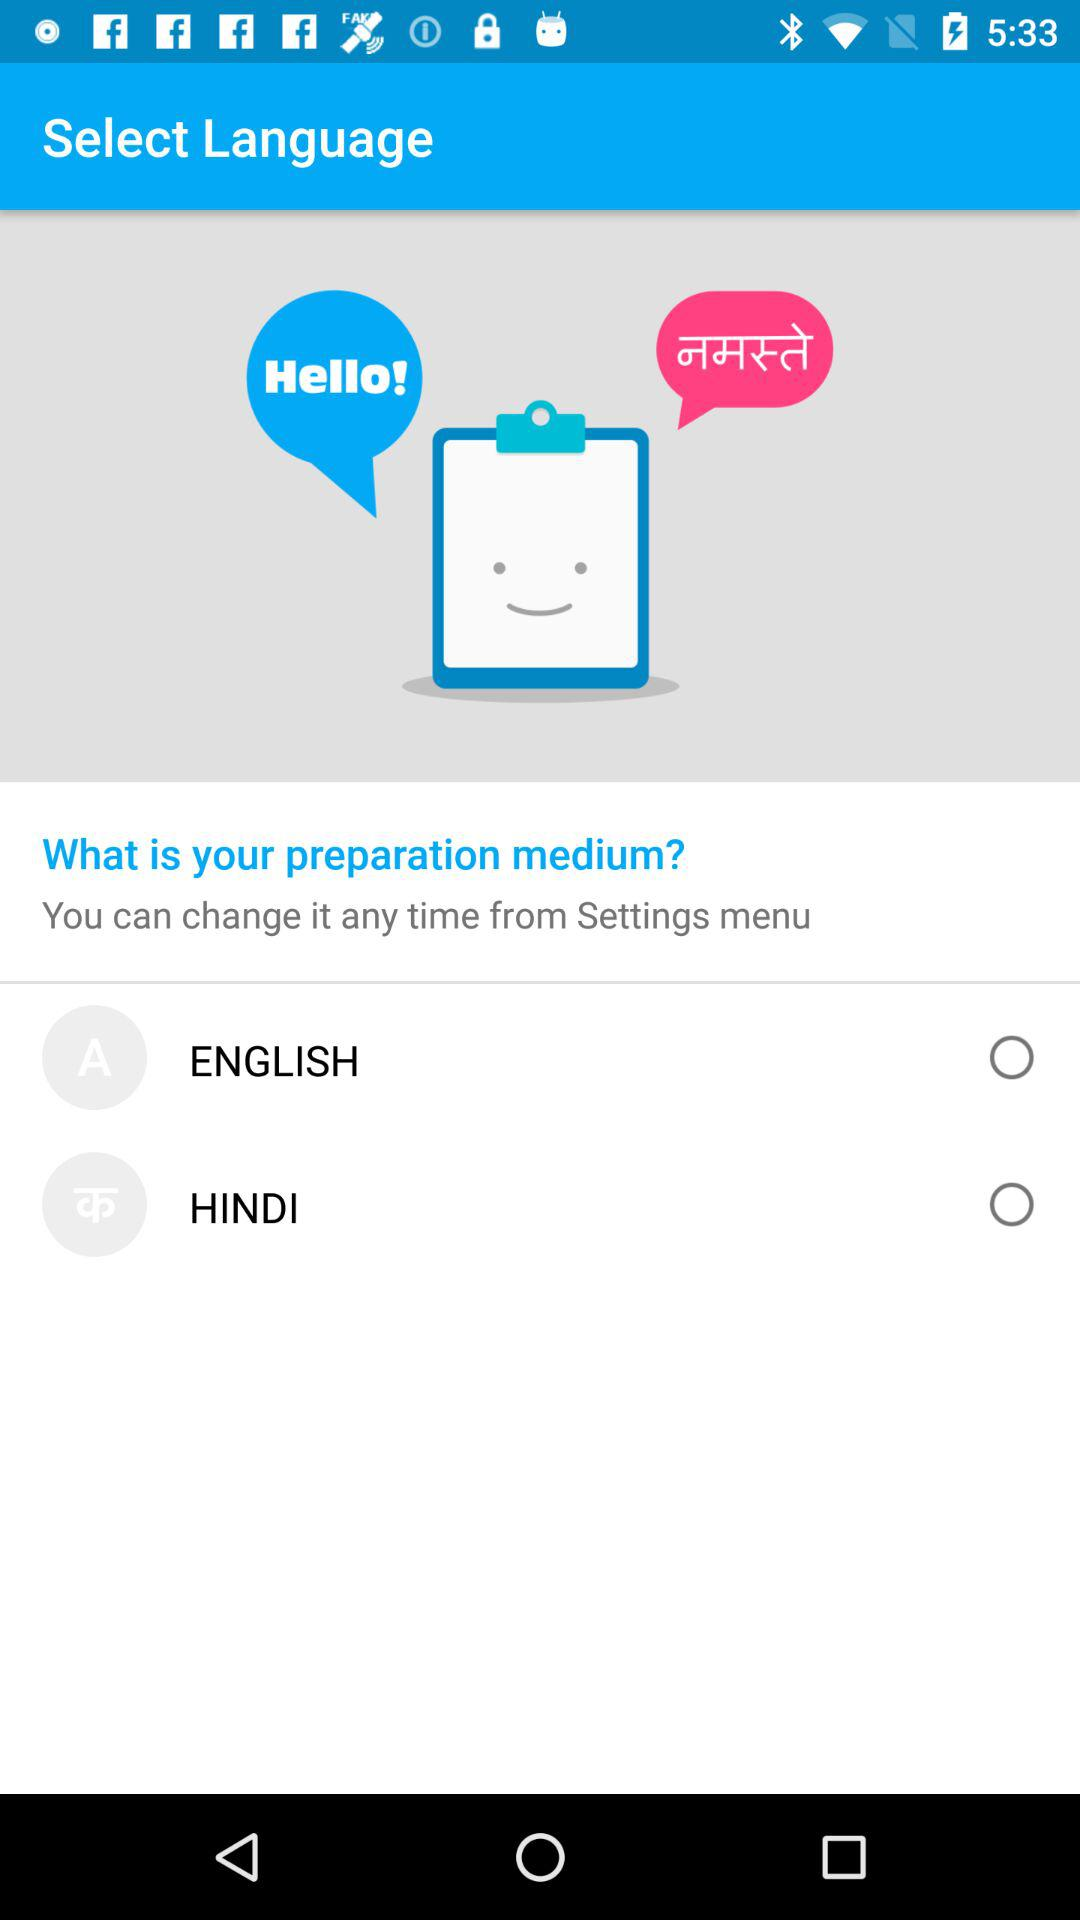Which language is selected?
When the provided information is insufficient, respond with <no answer>. <no answer> 